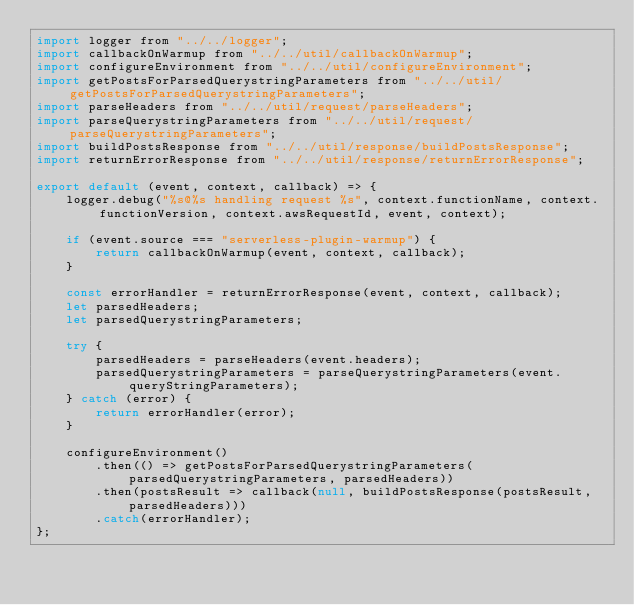<code> <loc_0><loc_0><loc_500><loc_500><_JavaScript_>import logger from "../../logger";
import callbackOnWarmup from "../../util/callbackOnWarmup";
import configureEnvironment from "../../util/configureEnvironment";
import getPostsForParsedQuerystringParameters from "../../util/getPostsForParsedQuerystringParameters";
import parseHeaders from "../../util/request/parseHeaders";
import parseQuerystringParameters from "../../util/request/parseQuerystringParameters";
import buildPostsResponse from "../../util/response/buildPostsResponse";
import returnErrorResponse from "../../util/response/returnErrorResponse";

export default (event, context, callback) => {
    logger.debug("%s@%s handling request %s", context.functionName, context.functionVersion, context.awsRequestId, event, context);

    if (event.source === "serverless-plugin-warmup") {
        return callbackOnWarmup(event, context, callback);
    }

    const errorHandler = returnErrorResponse(event, context, callback);
    let parsedHeaders;
    let parsedQuerystringParameters;

    try {
        parsedHeaders = parseHeaders(event.headers);
        parsedQuerystringParameters = parseQuerystringParameters(event.queryStringParameters);
    } catch (error) {
        return errorHandler(error);
    }

    configureEnvironment()
        .then(() => getPostsForParsedQuerystringParameters(parsedQuerystringParameters, parsedHeaders))
        .then(postsResult => callback(null, buildPostsResponse(postsResult, parsedHeaders)))
        .catch(errorHandler);
};
</code> 